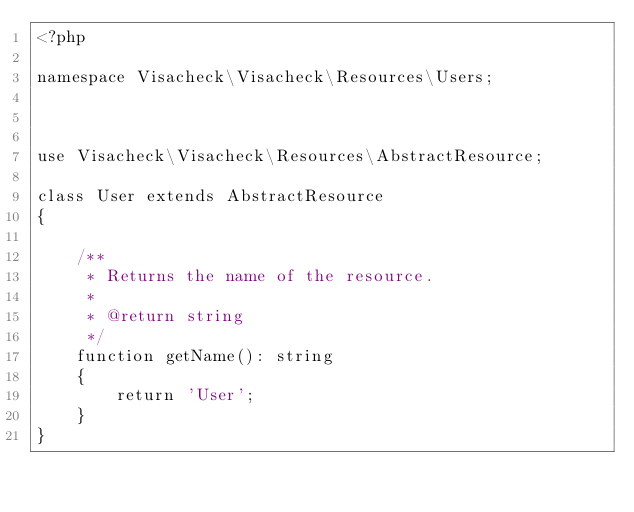Convert code to text. <code><loc_0><loc_0><loc_500><loc_500><_PHP_><?php

namespace Visacheck\Visacheck\Resources\Users;



use Visacheck\Visacheck\Resources\AbstractResource;

class User extends AbstractResource
{

    /**
     * Returns the name of the resource.
     *
     * @return string
     */
    function getName(): string
    {
        return 'User';
    }
}</code> 